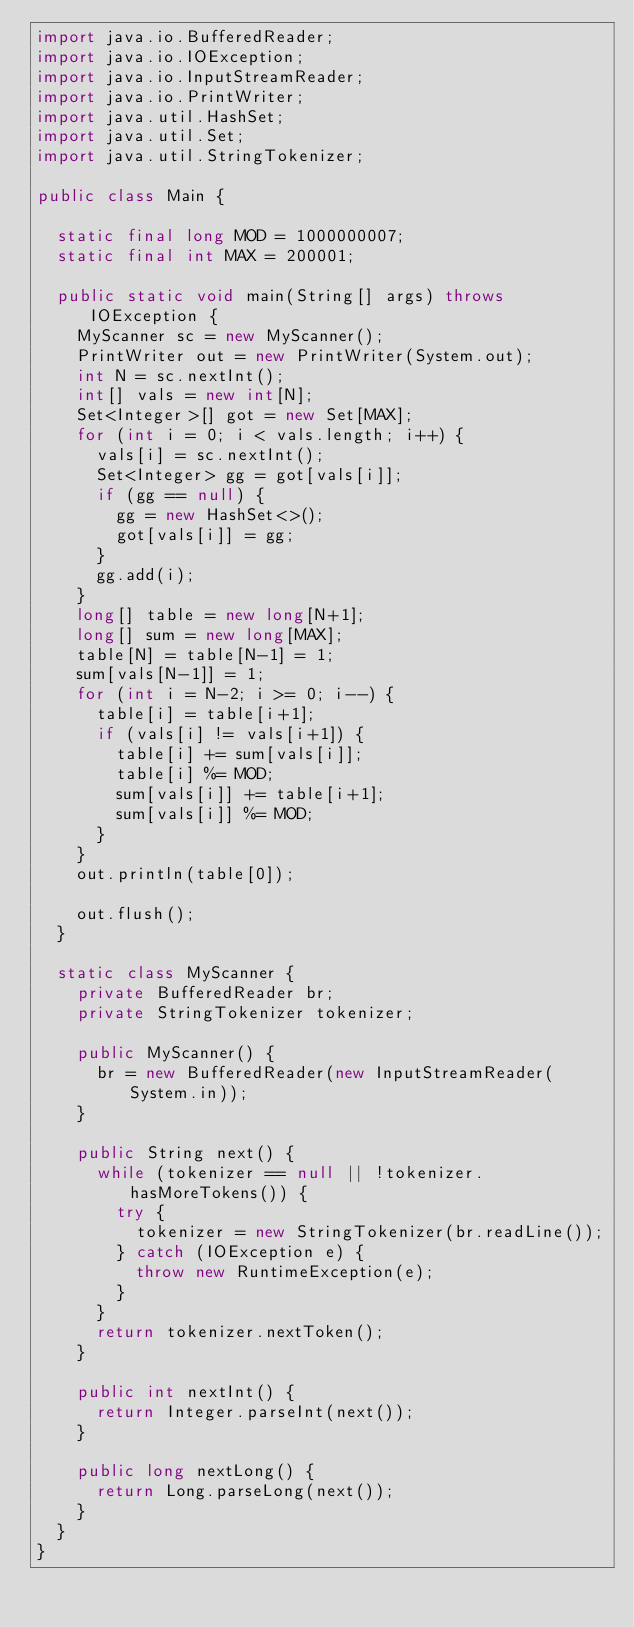Convert code to text. <code><loc_0><loc_0><loc_500><loc_500><_Java_>import java.io.BufferedReader;
import java.io.IOException;
import java.io.InputStreamReader;
import java.io.PrintWriter;
import java.util.HashSet;
import java.util.Set;
import java.util.StringTokenizer;

public class Main {
	
	static final long MOD = 1000000007;
	static final int MAX = 200001;
	
	public static void main(String[] args) throws IOException {
		MyScanner sc = new MyScanner();
		PrintWriter out = new PrintWriter(System.out);
		int N = sc.nextInt();
		int[] vals = new int[N];
		Set<Integer>[] got = new Set[MAX];
		for (int i = 0; i < vals.length; i++) {
			vals[i] = sc.nextInt();
			Set<Integer> gg = got[vals[i]];
			if (gg == null) {
				gg = new HashSet<>();
				got[vals[i]] = gg;
			}
			gg.add(i);
		}
		long[] table = new long[N+1];
		long[] sum = new long[MAX];
		table[N] = table[N-1] = 1;
		sum[vals[N-1]] = 1;
		for (int i = N-2; i >= 0; i--) {
			table[i] = table[i+1];
			if (vals[i] != vals[i+1]) {
				table[i] += sum[vals[i]];
				table[i] %= MOD;
				sum[vals[i]] += table[i+1];
				sum[vals[i]] %= MOD;
			}
		}
		out.println(table[0]);
		
		out.flush();
	}
	
	static class MyScanner {
		private BufferedReader br;
		private StringTokenizer tokenizer;
		
		public MyScanner() {
			br = new BufferedReader(new InputStreamReader(System.in));
		}
		
		public String next() {
			while (tokenizer == null || !tokenizer.hasMoreTokens()) {
				try {
					tokenizer = new StringTokenizer(br.readLine());
				} catch (IOException e) {
					throw new RuntimeException(e);
				}
			}
			return tokenizer.nextToken();
		}
		
		public int nextInt() {
			return Integer.parseInt(next());
		}
		
		public long nextLong() {
			return Long.parseLong(next());
		}
	}
}
</code> 